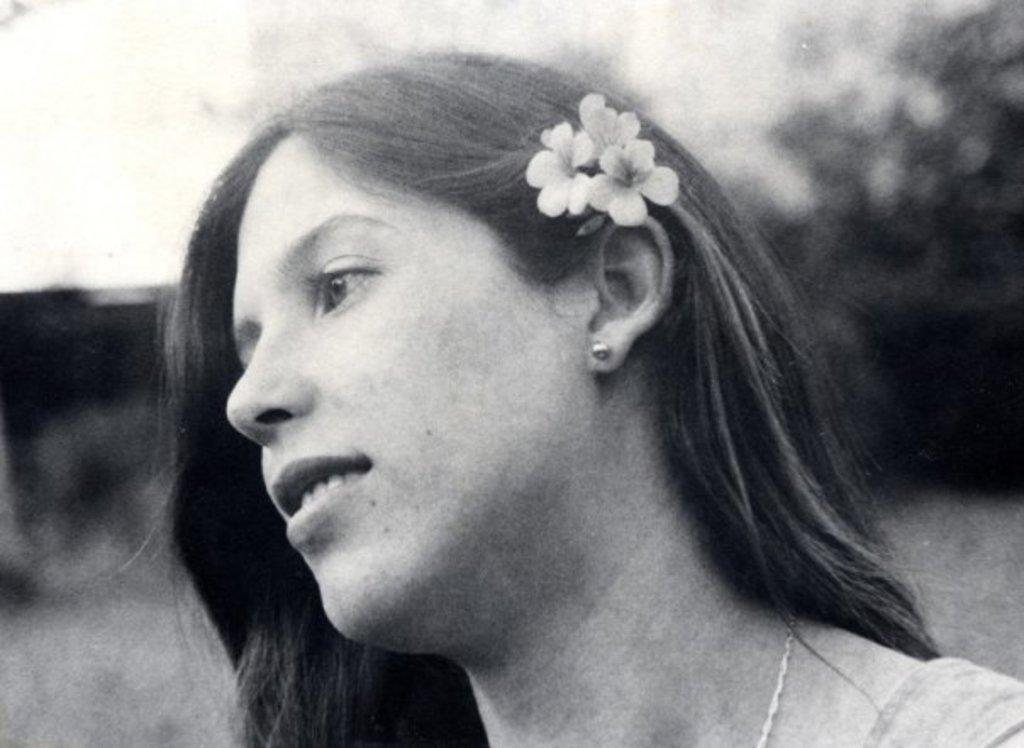Please provide a concise description of this image. It is a black and white image. In this image we can see a woman with the flowers and the background is blurred. 